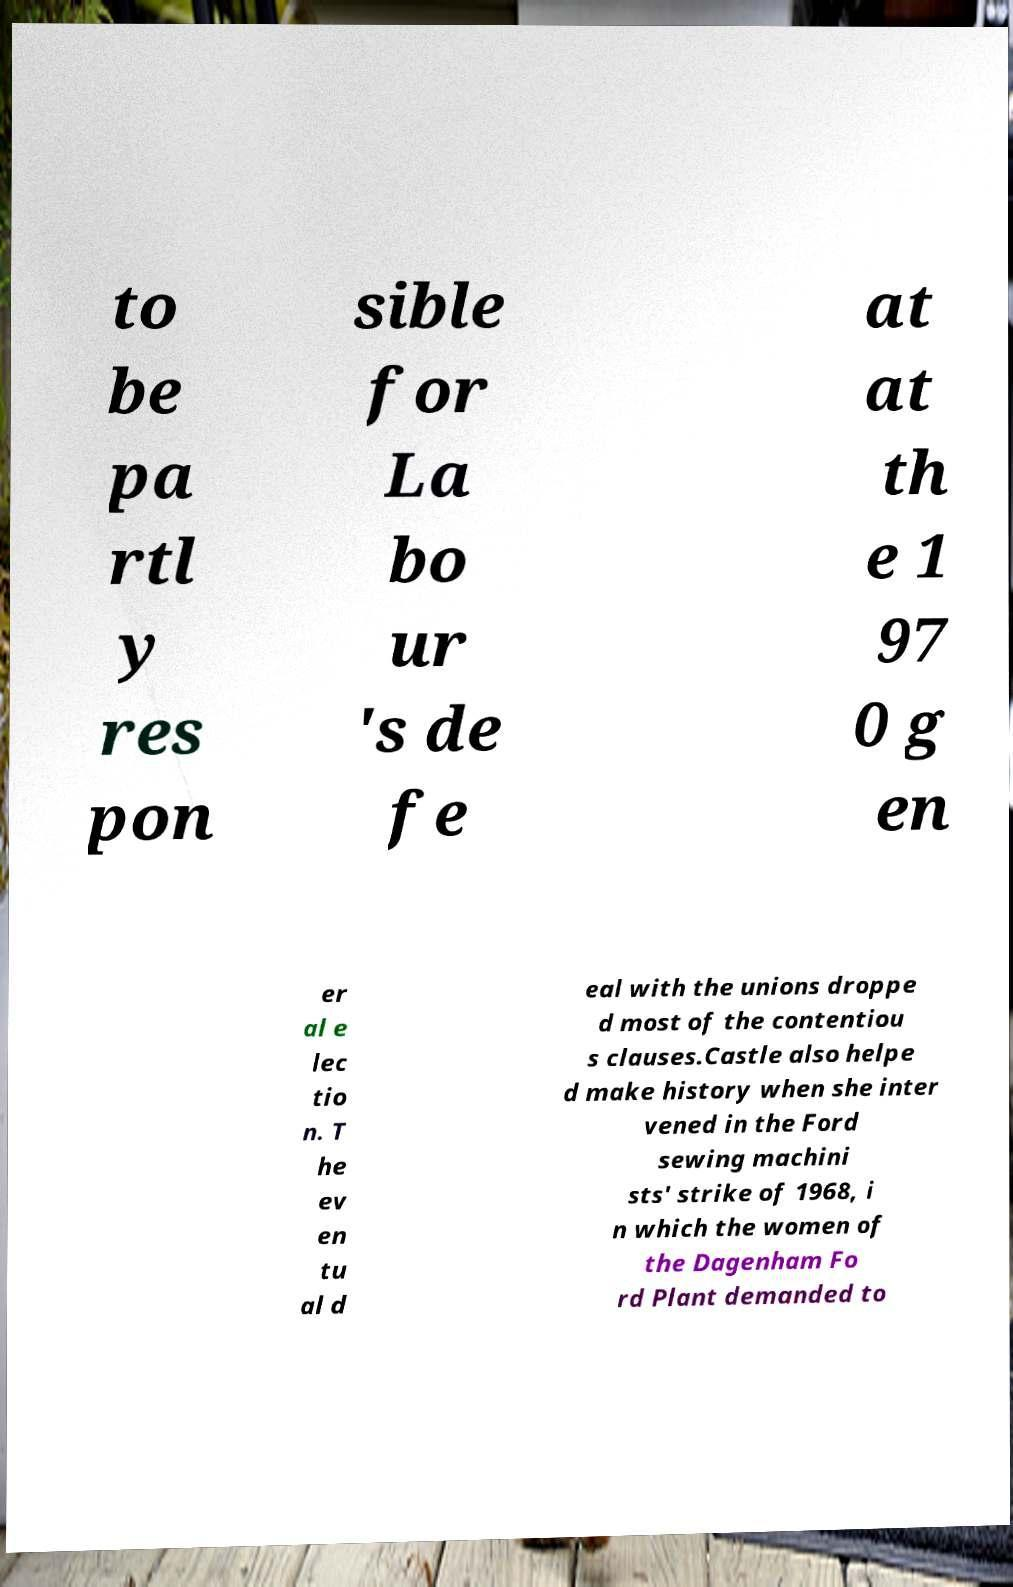Please read and relay the text visible in this image. What does it say? to be pa rtl y res pon sible for La bo ur 's de fe at at th e 1 97 0 g en er al e lec tio n. T he ev en tu al d eal with the unions droppe d most of the contentiou s clauses.Castle also helpe d make history when she inter vened in the Ford sewing machini sts' strike of 1968, i n which the women of the Dagenham Fo rd Plant demanded to 